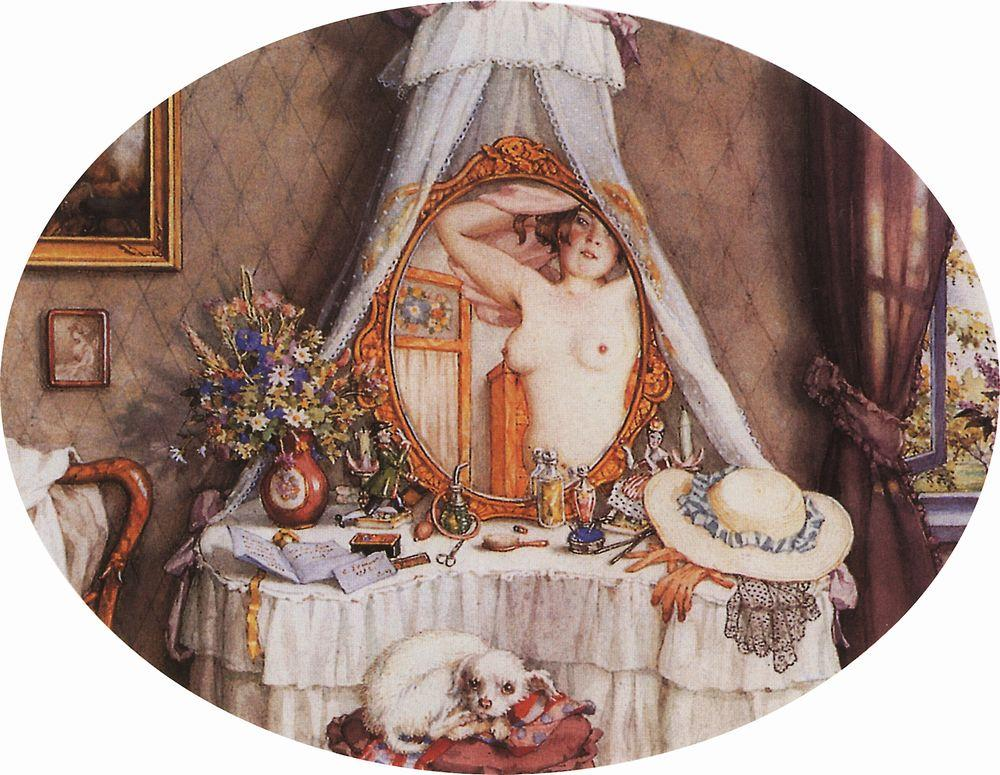What do you think is going on in this snapshot? The image portrays a richly detailed scene set in a cozy bedroom, where a woman is depicted standing nude in front of a vanity mirror. Her arms are gracefully raised above her head, possibly in a moment of self-admiration or preparation. She is slightly veiled by a delicate white canopy that drapes elegantly over her. The surrounding environment is meticulously adorned with various personal effects: a hat resting on the vanity suggests a touch of fashionable flair; a vase brimming with vibrant flowers brings a burst of natural beauty; and a small, fluffy dog resting comfortably on a red cushion adds a sense of homely companionship. The art style has an impressionistic quality, characterized by a soft color palette and loose brushstrokes, focusing on capturing the essence of the moment rather than precise details. The painting likely falls into the category of genre painting, emphasizing the private, everyday life and emotional undertones of the scene. 